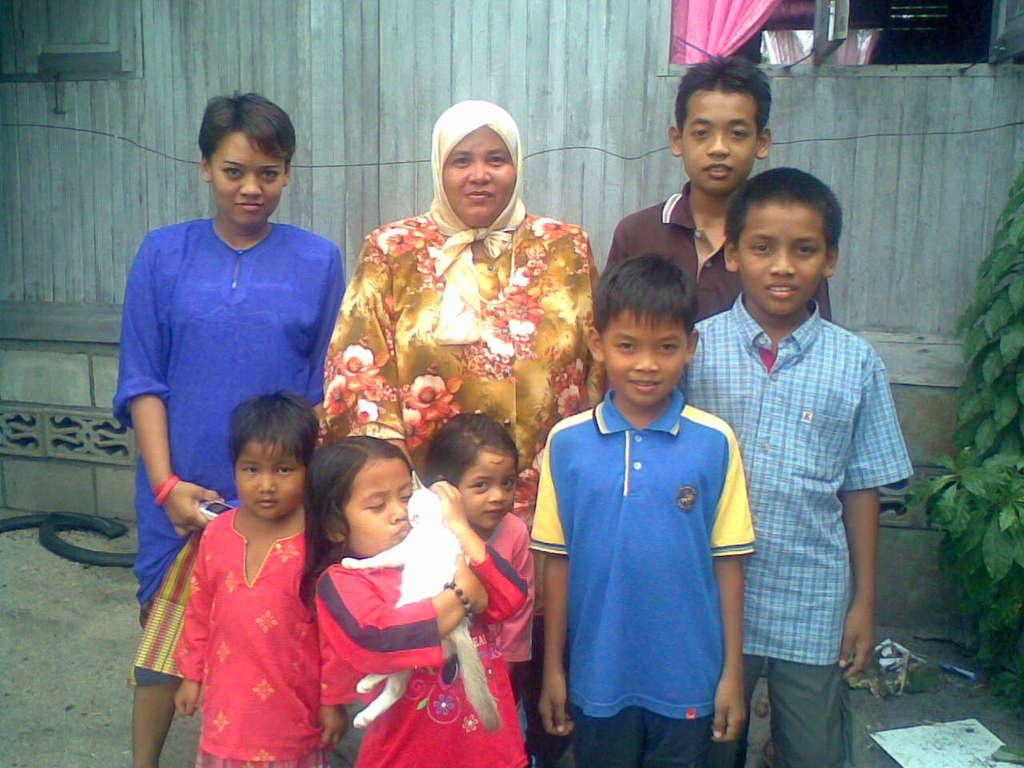What are the people in the image doing? The people in the image are standing and smiling. What can be seen behind the people? There is a wall behind the people. What is on the right side of the image? There is a plant and a girl holding a cat on the right side of the image. What type of quartz can be seen in the image? There is no quartz present in the image. How many fingers does the girl have on her right hand in the image? The image does not provide enough detail to determine the number of fingers the girl has on her right hand. 